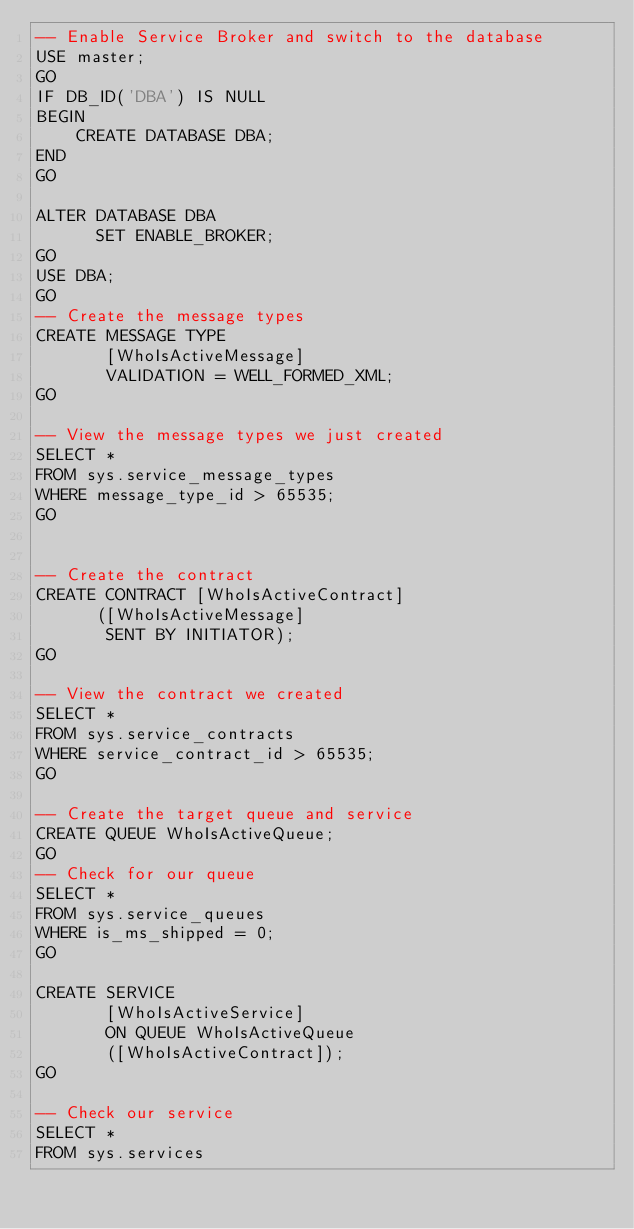<code> <loc_0><loc_0><loc_500><loc_500><_SQL_>-- Enable Service Broker and switch to the database
USE master;
GO
IF DB_ID('DBA') IS NULL
BEGIN
	CREATE DATABASE DBA;
END
GO

ALTER DATABASE DBA
      SET ENABLE_BROKER;
GO
USE DBA;
GO
-- Create the message types
CREATE MESSAGE TYPE
       [WhoIsActiveMessage]
       VALIDATION = WELL_FORMED_XML;
GO

-- View the message types we just created
SELECT * 
FROM sys.service_message_types
WHERE message_type_id > 65535;
GO


-- Create the contract
CREATE CONTRACT [WhoIsActiveContract]
      ([WhoIsActiveMessage]
       SENT BY INITIATOR);
GO

-- View the contract we created
SELECT *
FROM sys.service_contracts
WHERE service_contract_id > 65535;
GO

-- Create the target queue and service
CREATE QUEUE WhoIsActiveQueue;
GO
-- Check for our queue
SELECT * 
FROM sys.service_queues
WHERE is_ms_shipped = 0;
GO

CREATE SERVICE
       [WhoIsActiveService]
       ON QUEUE WhoIsActiveQueue
       ([WhoIsActiveContract]);
GO

-- Check our service
SELECT *
FROM sys.services</code> 